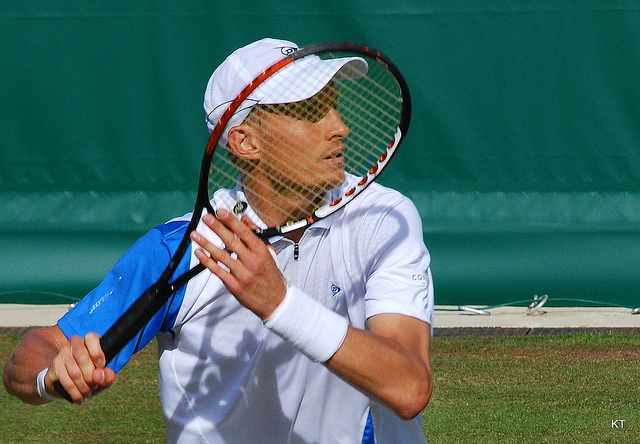Identify the text displayed in this image. CO KT 